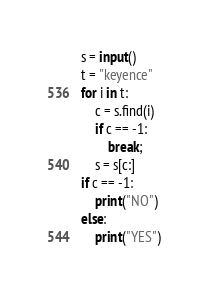Convert code to text. <code><loc_0><loc_0><loc_500><loc_500><_Python_>s = input()
t = "keyence"
for i in t:
    c = s.find(i)
    if c == -1:
        break;
    s = s[c:]
if c == -1:
    print("NO")
else:
    print("YES")
</code> 